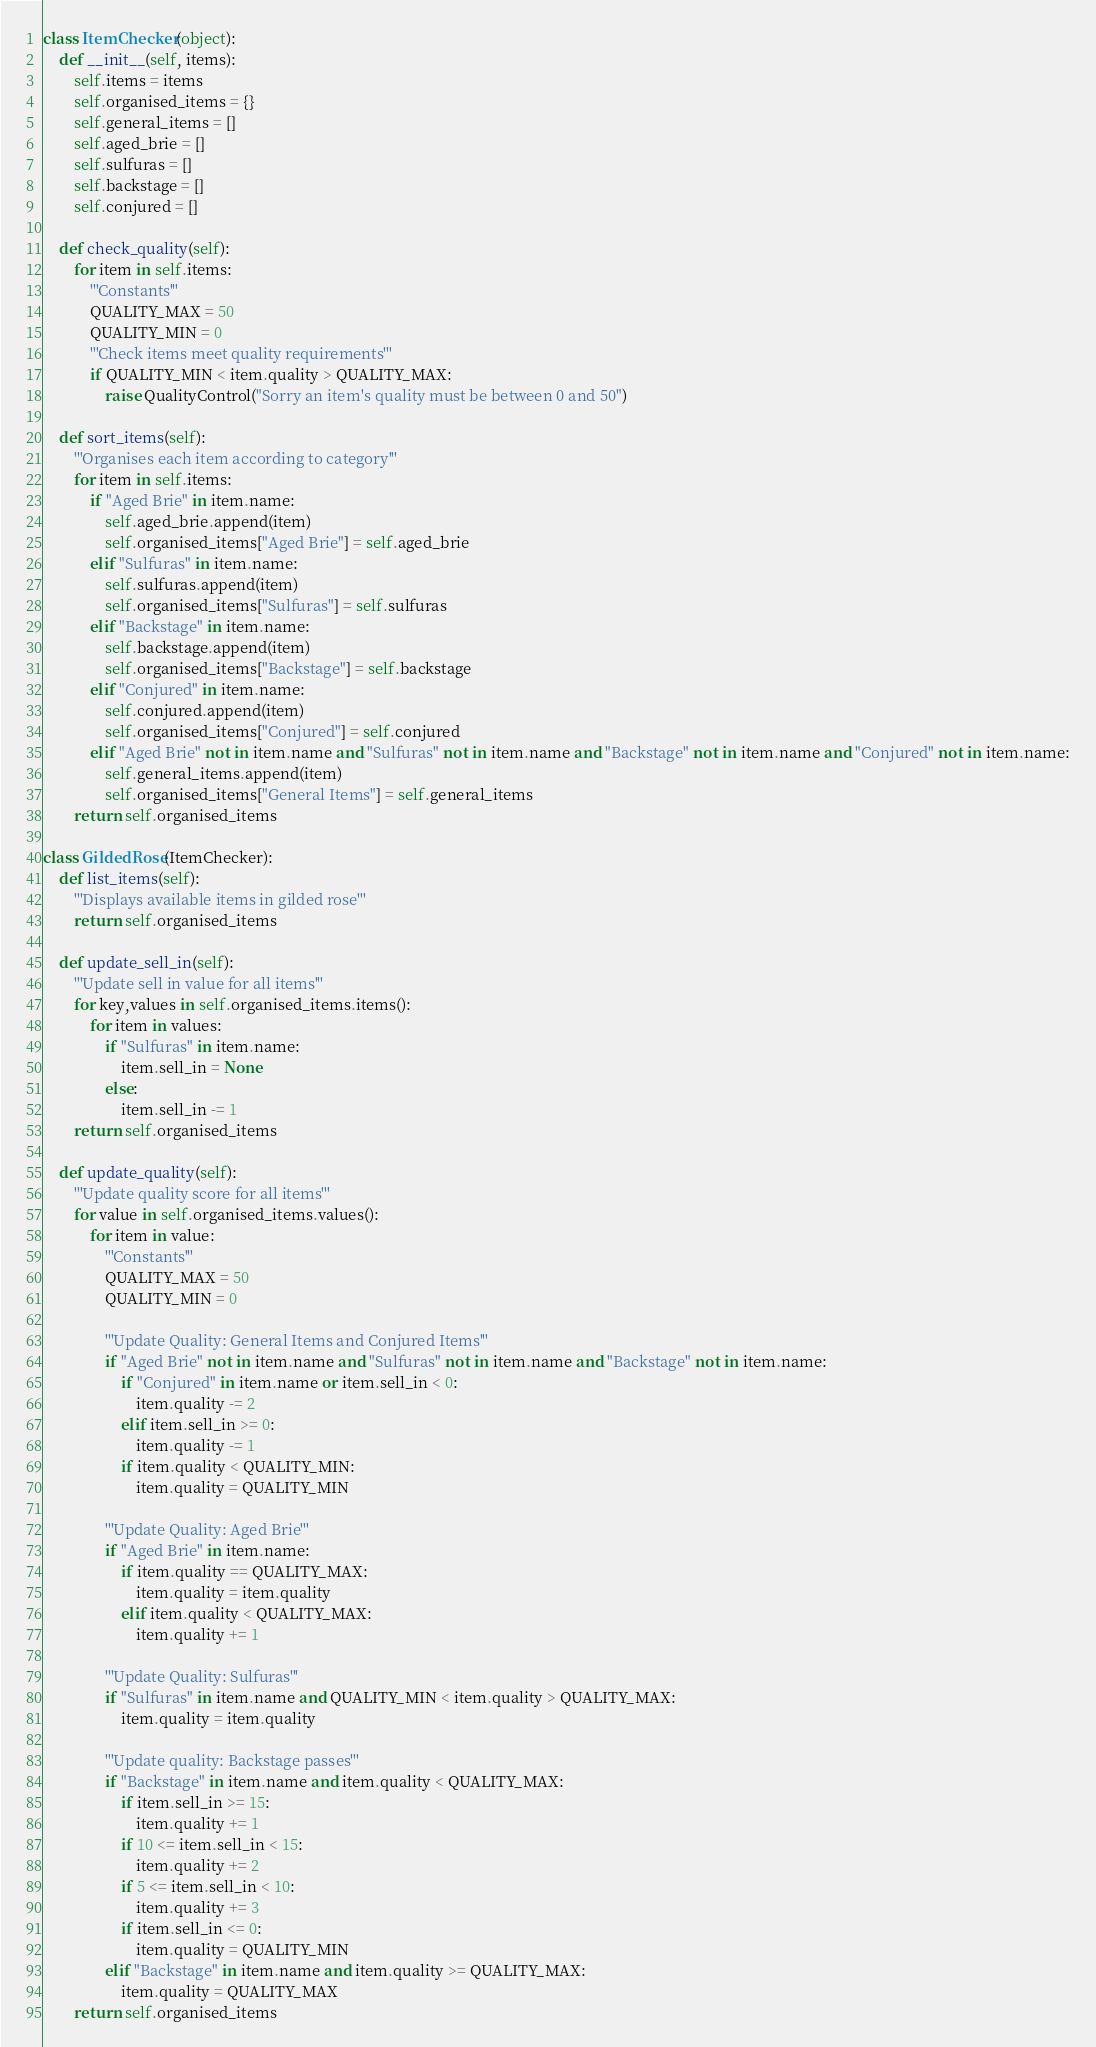<code> <loc_0><loc_0><loc_500><loc_500><_Python_>
class ItemChecker(object):
    def __init__(self, items):
        self.items = items
        self.organised_items = {}
        self.general_items = []
        self.aged_brie = []
        self.sulfuras = []
        self.backstage = []
        self.conjured = []

    def check_quality(self):
        for item in self.items:
            '''Constants'''
            QUALITY_MAX = 50
            QUALITY_MIN = 0
            '''Check items meet quality requirements'''
            if QUALITY_MIN < item.quality > QUALITY_MAX:
                raise QualityControl("Sorry an item's quality must be between 0 and 50")
    
    def sort_items(self):
        '''Organises each item according to category'''
        for item in self.items:
            if "Aged Brie" in item.name:
                self.aged_brie.append(item)
                self.organised_items["Aged Brie"] = self.aged_brie
            elif "Sulfuras" in item.name:
                self.sulfuras.append(item)
                self.organised_items["Sulfuras"] = self.sulfuras
            elif "Backstage" in item.name:
                self.backstage.append(item)
                self.organised_items["Backstage"] = self.backstage
            elif "Conjured" in item.name:
                self.conjured.append(item)
                self.organised_items["Conjured"] = self.conjured
            elif "Aged Brie" not in item.name and "Sulfuras" not in item.name and "Backstage" not in item.name and "Conjured" not in item.name:
                self.general_items.append(item)
                self.organised_items["General Items"] = self.general_items
        return self.organised_items

class GildedRose(ItemChecker):
    def list_items(self):
        '''Displays available items in gilded rose'''
        return self.organised_items
             
    def update_sell_in(self):
        '''Update sell in value for all items'''
        for key,values in self.organised_items.items():
            for item in values:
                if "Sulfuras" in item.name:
                    item.sell_in = None
                else:
                    item.sell_in -= 1
        return self.organised_items
    
    def update_quality(self):
        '''Update quality score for all items'''
        for value in self.organised_items.values():
            for item in value:
                '''Constants'''
                QUALITY_MAX = 50
                QUALITY_MIN = 0

                '''Update Quality: General Items and Conjured Items'''
                if "Aged Brie" not in item.name and "Sulfuras" not in item.name and "Backstage" not in item.name:
                    if "Conjured" in item.name or item.sell_in < 0:
                        item.quality -= 2
                    elif item.sell_in >= 0:
                        item.quality -= 1
                    if item.quality < QUALITY_MIN:
                        item.quality = QUALITY_MIN

                '''Update Quality: Aged Brie'''
                if "Aged Brie" in item.name:
                    if item.quality == QUALITY_MAX:
                        item.quality = item.quality
                    elif item.quality < QUALITY_MAX:
                        item.quality += 1 

                '''Update Quality: Sulfuras'''
                if "Sulfuras" in item.name and QUALITY_MIN < item.quality > QUALITY_MAX:
                    item.quality = item.quality

                '''Update quality: Backstage passes'''
                if "Backstage" in item.name and item.quality < QUALITY_MAX:
                    if item.sell_in >= 15:
                        item.quality += 1
                    if 10 <= item.sell_in < 15:
                        item.quality += 2
                    if 5 <= item.sell_in < 10:
                        item.quality += 3
                    if item.sell_in <= 0:
                        item.quality = QUALITY_MIN
                elif "Backstage" in item.name and item.quality >= QUALITY_MAX:
                    item.quality = QUALITY_MAX
        return self.organised_items




</code> 